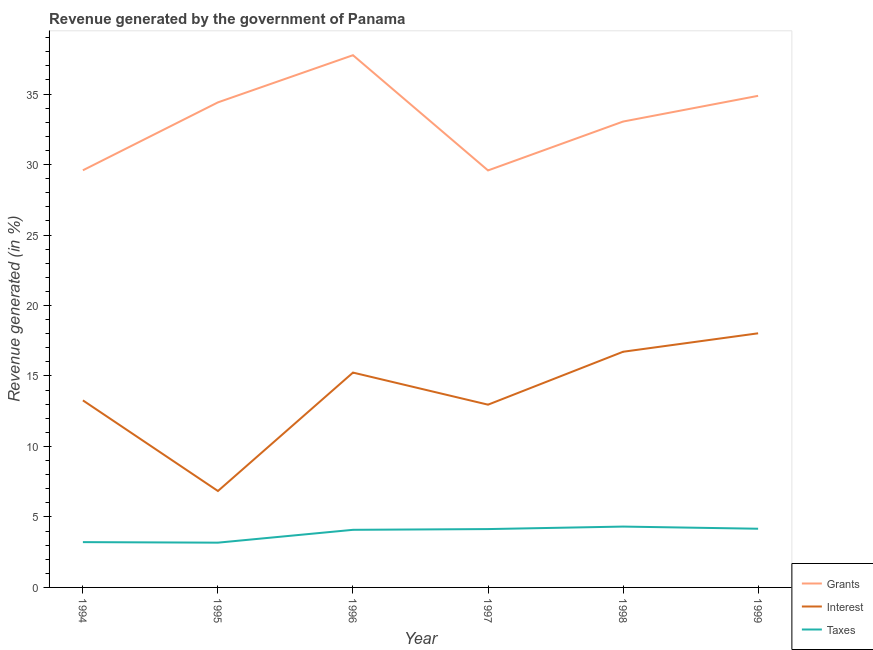How many different coloured lines are there?
Offer a very short reply. 3. Is the number of lines equal to the number of legend labels?
Your answer should be compact. Yes. What is the percentage of revenue generated by taxes in 1996?
Offer a terse response. 4.09. Across all years, what is the maximum percentage of revenue generated by interest?
Your answer should be compact. 18.03. Across all years, what is the minimum percentage of revenue generated by taxes?
Your answer should be compact. 3.18. In which year was the percentage of revenue generated by grants minimum?
Offer a very short reply. 1997. What is the total percentage of revenue generated by grants in the graph?
Your response must be concise. 199.27. What is the difference between the percentage of revenue generated by taxes in 1994 and that in 1996?
Offer a very short reply. -0.87. What is the difference between the percentage of revenue generated by grants in 1994 and the percentage of revenue generated by taxes in 1998?
Your response must be concise. 25.28. What is the average percentage of revenue generated by taxes per year?
Ensure brevity in your answer.  3.85. In the year 1996, what is the difference between the percentage of revenue generated by grants and percentage of revenue generated by interest?
Your answer should be compact. 22.52. In how many years, is the percentage of revenue generated by interest greater than 29 %?
Provide a succinct answer. 0. What is the ratio of the percentage of revenue generated by interest in 1994 to that in 1999?
Your answer should be very brief. 0.74. Is the percentage of revenue generated by grants in 1998 less than that in 1999?
Provide a succinct answer. Yes. Is the difference between the percentage of revenue generated by interest in 1994 and 1996 greater than the difference between the percentage of revenue generated by grants in 1994 and 1996?
Make the answer very short. Yes. What is the difference between the highest and the second highest percentage of revenue generated by taxes?
Give a very brief answer. 0.15. What is the difference between the highest and the lowest percentage of revenue generated by taxes?
Provide a succinct answer. 1.14. In how many years, is the percentage of revenue generated by interest greater than the average percentage of revenue generated by interest taken over all years?
Your answer should be compact. 3. Is the sum of the percentage of revenue generated by interest in 1994 and 1995 greater than the maximum percentage of revenue generated by grants across all years?
Offer a terse response. No. Is it the case that in every year, the sum of the percentage of revenue generated by grants and percentage of revenue generated by interest is greater than the percentage of revenue generated by taxes?
Give a very brief answer. Yes. How many years are there in the graph?
Provide a short and direct response. 6. What is the difference between two consecutive major ticks on the Y-axis?
Provide a short and direct response. 5. Are the values on the major ticks of Y-axis written in scientific E-notation?
Provide a short and direct response. No. How many legend labels are there?
Your answer should be very brief. 3. How are the legend labels stacked?
Offer a very short reply. Vertical. What is the title of the graph?
Provide a succinct answer. Revenue generated by the government of Panama. What is the label or title of the Y-axis?
Provide a succinct answer. Revenue generated (in %). What is the Revenue generated (in %) of Grants in 1994?
Offer a terse response. 29.59. What is the Revenue generated (in %) in Interest in 1994?
Keep it short and to the point. 13.27. What is the Revenue generated (in %) in Taxes in 1994?
Offer a terse response. 3.21. What is the Revenue generated (in %) in Grants in 1995?
Give a very brief answer. 34.41. What is the Revenue generated (in %) in Interest in 1995?
Offer a very short reply. 6.84. What is the Revenue generated (in %) in Taxes in 1995?
Your answer should be compact. 3.18. What is the Revenue generated (in %) of Grants in 1996?
Your answer should be compact. 37.76. What is the Revenue generated (in %) in Interest in 1996?
Your answer should be very brief. 15.24. What is the Revenue generated (in %) of Taxes in 1996?
Your answer should be very brief. 4.09. What is the Revenue generated (in %) of Grants in 1997?
Your answer should be compact. 29.58. What is the Revenue generated (in %) in Interest in 1997?
Your answer should be compact. 12.96. What is the Revenue generated (in %) of Taxes in 1997?
Your response must be concise. 4.14. What is the Revenue generated (in %) of Grants in 1998?
Your answer should be very brief. 33.05. What is the Revenue generated (in %) of Interest in 1998?
Ensure brevity in your answer.  16.72. What is the Revenue generated (in %) in Taxes in 1998?
Provide a short and direct response. 4.32. What is the Revenue generated (in %) of Grants in 1999?
Your answer should be very brief. 34.88. What is the Revenue generated (in %) in Interest in 1999?
Make the answer very short. 18.03. What is the Revenue generated (in %) in Taxes in 1999?
Ensure brevity in your answer.  4.16. Across all years, what is the maximum Revenue generated (in %) of Grants?
Your answer should be very brief. 37.76. Across all years, what is the maximum Revenue generated (in %) in Interest?
Your answer should be very brief. 18.03. Across all years, what is the maximum Revenue generated (in %) of Taxes?
Your answer should be compact. 4.32. Across all years, what is the minimum Revenue generated (in %) of Grants?
Ensure brevity in your answer.  29.58. Across all years, what is the minimum Revenue generated (in %) in Interest?
Offer a terse response. 6.84. Across all years, what is the minimum Revenue generated (in %) of Taxes?
Ensure brevity in your answer.  3.18. What is the total Revenue generated (in %) in Grants in the graph?
Your answer should be very brief. 199.27. What is the total Revenue generated (in %) in Interest in the graph?
Keep it short and to the point. 83.06. What is the total Revenue generated (in %) of Taxes in the graph?
Make the answer very short. 23.1. What is the difference between the Revenue generated (in %) of Grants in 1994 and that in 1995?
Your answer should be compact. -4.82. What is the difference between the Revenue generated (in %) in Interest in 1994 and that in 1995?
Offer a very short reply. 6.43. What is the difference between the Revenue generated (in %) in Taxes in 1994 and that in 1995?
Your answer should be very brief. 0.04. What is the difference between the Revenue generated (in %) of Grants in 1994 and that in 1996?
Keep it short and to the point. -8.17. What is the difference between the Revenue generated (in %) in Interest in 1994 and that in 1996?
Provide a succinct answer. -1.97. What is the difference between the Revenue generated (in %) in Taxes in 1994 and that in 1996?
Keep it short and to the point. -0.87. What is the difference between the Revenue generated (in %) in Grants in 1994 and that in 1997?
Keep it short and to the point. 0.01. What is the difference between the Revenue generated (in %) of Interest in 1994 and that in 1997?
Make the answer very short. 0.31. What is the difference between the Revenue generated (in %) in Taxes in 1994 and that in 1997?
Offer a terse response. -0.93. What is the difference between the Revenue generated (in %) of Grants in 1994 and that in 1998?
Offer a terse response. -3.46. What is the difference between the Revenue generated (in %) of Interest in 1994 and that in 1998?
Your answer should be very brief. -3.45. What is the difference between the Revenue generated (in %) of Taxes in 1994 and that in 1998?
Your answer should be compact. -1.1. What is the difference between the Revenue generated (in %) in Grants in 1994 and that in 1999?
Your answer should be very brief. -5.28. What is the difference between the Revenue generated (in %) in Interest in 1994 and that in 1999?
Provide a succinct answer. -4.76. What is the difference between the Revenue generated (in %) in Taxes in 1994 and that in 1999?
Ensure brevity in your answer.  -0.95. What is the difference between the Revenue generated (in %) in Grants in 1995 and that in 1996?
Your answer should be very brief. -3.35. What is the difference between the Revenue generated (in %) in Interest in 1995 and that in 1996?
Make the answer very short. -8.4. What is the difference between the Revenue generated (in %) of Taxes in 1995 and that in 1996?
Provide a short and direct response. -0.91. What is the difference between the Revenue generated (in %) of Grants in 1995 and that in 1997?
Provide a short and direct response. 4.83. What is the difference between the Revenue generated (in %) in Interest in 1995 and that in 1997?
Give a very brief answer. -6.13. What is the difference between the Revenue generated (in %) of Taxes in 1995 and that in 1997?
Your response must be concise. -0.96. What is the difference between the Revenue generated (in %) of Grants in 1995 and that in 1998?
Make the answer very short. 1.36. What is the difference between the Revenue generated (in %) in Interest in 1995 and that in 1998?
Make the answer very short. -9.88. What is the difference between the Revenue generated (in %) of Taxes in 1995 and that in 1998?
Offer a terse response. -1.14. What is the difference between the Revenue generated (in %) in Grants in 1995 and that in 1999?
Offer a terse response. -0.46. What is the difference between the Revenue generated (in %) of Interest in 1995 and that in 1999?
Your answer should be compact. -11.19. What is the difference between the Revenue generated (in %) of Taxes in 1995 and that in 1999?
Your response must be concise. -0.99. What is the difference between the Revenue generated (in %) in Grants in 1996 and that in 1997?
Provide a short and direct response. 8.17. What is the difference between the Revenue generated (in %) of Interest in 1996 and that in 1997?
Your answer should be very brief. 2.28. What is the difference between the Revenue generated (in %) in Taxes in 1996 and that in 1997?
Ensure brevity in your answer.  -0.05. What is the difference between the Revenue generated (in %) of Grants in 1996 and that in 1998?
Give a very brief answer. 4.71. What is the difference between the Revenue generated (in %) of Interest in 1996 and that in 1998?
Provide a succinct answer. -1.48. What is the difference between the Revenue generated (in %) in Taxes in 1996 and that in 1998?
Provide a short and direct response. -0.23. What is the difference between the Revenue generated (in %) of Grants in 1996 and that in 1999?
Provide a succinct answer. 2.88. What is the difference between the Revenue generated (in %) in Interest in 1996 and that in 1999?
Offer a very short reply. -2.79. What is the difference between the Revenue generated (in %) of Taxes in 1996 and that in 1999?
Keep it short and to the point. -0.08. What is the difference between the Revenue generated (in %) of Grants in 1997 and that in 1998?
Offer a very short reply. -3.47. What is the difference between the Revenue generated (in %) of Interest in 1997 and that in 1998?
Your response must be concise. -3.75. What is the difference between the Revenue generated (in %) of Taxes in 1997 and that in 1998?
Your response must be concise. -0.18. What is the difference between the Revenue generated (in %) of Grants in 1997 and that in 1999?
Offer a very short reply. -5.29. What is the difference between the Revenue generated (in %) in Interest in 1997 and that in 1999?
Your answer should be compact. -5.06. What is the difference between the Revenue generated (in %) of Taxes in 1997 and that in 1999?
Ensure brevity in your answer.  -0.03. What is the difference between the Revenue generated (in %) in Grants in 1998 and that in 1999?
Give a very brief answer. -1.82. What is the difference between the Revenue generated (in %) in Interest in 1998 and that in 1999?
Keep it short and to the point. -1.31. What is the difference between the Revenue generated (in %) of Taxes in 1998 and that in 1999?
Ensure brevity in your answer.  0.15. What is the difference between the Revenue generated (in %) of Grants in 1994 and the Revenue generated (in %) of Interest in 1995?
Your answer should be very brief. 22.75. What is the difference between the Revenue generated (in %) of Grants in 1994 and the Revenue generated (in %) of Taxes in 1995?
Give a very brief answer. 26.42. What is the difference between the Revenue generated (in %) in Interest in 1994 and the Revenue generated (in %) in Taxes in 1995?
Your response must be concise. 10.09. What is the difference between the Revenue generated (in %) of Grants in 1994 and the Revenue generated (in %) of Interest in 1996?
Your response must be concise. 14.35. What is the difference between the Revenue generated (in %) of Grants in 1994 and the Revenue generated (in %) of Taxes in 1996?
Your response must be concise. 25.51. What is the difference between the Revenue generated (in %) in Interest in 1994 and the Revenue generated (in %) in Taxes in 1996?
Give a very brief answer. 9.18. What is the difference between the Revenue generated (in %) of Grants in 1994 and the Revenue generated (in %) of Interest in 1997?
Make the answer very short. 16.63. What is the difference between the Revenue generated (in %) of Grants in 1994 and the Revenue generated (in %) of Taxes in 1997?
Your answer should be very brief. 25.45. What is the difference between the Revenue generated (in %) of Interest in 1994 and the Revenue generated (in %) of Taxes in 1997?
Make the answer very short. 9.13. What is the difference between the Revenue generated (in %) of Grants in 1994 and the Revenue generated (in %) of Interest in 1998?
Keep it short and to the point. 12.87. What is the difference between the Revenue generated (in %) in Grants in 1994 and the Revenue generated (in %) in Taxes in 1998?
Give a very brief answer. 25.28. What is the difference between the Revenue generated (in %) of Interest in 1994 and the Revenue generated (in %) of Taxes in 1998?
Make the answer very short. 8.95. What is the difference between the Revenue generated (in %) in Grants in 1994 and the Revenue generated (in %) in Interest in 1999?
Offer a very short reply. 11.56. What is the difference between the Revenue generated (in %) of Grants in 1994 and the Revenue generated (in %) of Taxes in 1999?
Keep it short and to the point. 25.43. What is the difference between the Revenue generated (in %) in Interest in 1994 and the Revenue generated (in %) in Taxes in 1999?
Keep it short and to the point. 9.11. What is the difference between the Revenue generated (in %) of Grants in 1995 and the Revenue generated (in %) of Interest in 1996?
Offer a very short reply. 19.17. What is the difference between the Revenue generated (in %) of Grants in 1995 and the Revenue generated (in %) of Taxes in 1996?
Keep it short and to the point. 30.32. What is the difference between the Revenue generated (in %) of Interest in 1995 and the Revenue generated (in %) of Taxes in 1996?
Offer a terse response. 2.75. What is the difference between the Revenue generated (in %) of Grants in 1995 and the Revenue generated (in %) of Interest in 1997?
Your answer should be compact. 21.45. What is the difference between the Revenue generated (in %) in Grants in 1995 and the Revenue generated (in %) in Taxes in 1997?
Make the answer very short. 30.27. What is the difference between the Revenue generated (in %) of Interest in 1995 and the Revenue generated (in %) of Taxes in 1997?
Ensure brevity in your answer.  2.7. What is the difference between the Revenue generated (in %) of Grants in 1995 and the Revenue generated (in %) of Interest in 1998?
Offer a terse response. 17.69. What is the difference between the Revenue generated (in %) in Grants in 1995 and the Revenue generated (in %) in Taxes in 1998?
Offer a very short reply. 30.09. What is the difference between the Revenue generated (in %) of Interest in 1995 and the Revenue generated (in %) of Taxes in 1998?
Your answer should be very brief. 2.52. What is the difference between the Revenue generated (in %) in Grants in 1995 and the Revenue generated (in %) in Interest in 1999?
Ensure brevity in your answer.  16.38. What is the difference between the Revenue generated (in %) in Grants in 1995 and the Revenue generated (in %) in Taxes in 1999?
Your response must be concise. 30.25. What is the difference between the Revenue generated (in %) of Interest in 1995 and the Revenue generated (in %) of Taxes in 1999?
Provide a succinct answer. 2.68. What is the difference between the Revenue generated (in %) of Grants in 1996 and the Revenue generated (in %) of Interest in 1997?
Provide a short and direct response. 24.79. What is the difference between the Revenue generated (in %) in Grants in 1996 and the Revenue generated (in %) in Taxes in 1997?
Your response must be concise. 33.62. What is the difference between the Revenue generated (in %) in Interest in 1996 and the Revenue generated (in %) in Taxes in 1997?
Your response must be concise. 11.1. What is the difference between the Revenue generated (in %) in Grants in 1996 and the Revenue generated (in %) in Interest in 1998?
Provide a short and direct response. 21.04. What is the difference between the Revenue generated (in %) of Grants in 1996 and the Revenue generated (in %) of Taxes in 1998?
Make the answer very short. 33.44. What is the difference between the Revenue generated (in %) of Interest in 1996 and the Revenue generated (in %) of Taxes in 1998?
Give a very brief answer. 10.93. What is the difference between the Revenue generated (in %) in Grants in 1996 and the Revenue generated (in %) in Interest in 1999?
Offer a terse response. 19.73. What is the difference between the Revenue generated (in %) of Grants in 1996 and the Revenue generated (in %) of Taxes in 1999?
Your answer should be very brief. 33.59. What is the difference between the Revenue generated (in %) of Interest in 1996 and the Revenue generated (in %) of Taxes in 1999?
Make the answer very short. 11.08. What is the difference between the Revenue generated (in %) in Grants in 1997 and the Revenue generated (in %) in Interest in 1998?
Your response must be concise. 12.86. What is the difference between the Revenue generated (in %) of Grants in 1997 and the Revenue generated (in %) of Taxes in 1998?
Offer a very short reply. 25.27. What is the difference between the Revenue generated (in %) of Interest in 1997 and the Revenue generated (in %) of Taxes in 1998?
Offer a very short reply. 8.65. What is the difference between the Revenue generated (in %) of Grants in 1997 and the Revenue generated (in %) of Interest in 1999?
Provide a short and direct response. 11.56. What is the difference between the Revenue generated (in %) in Grants in 1997 and the Revenue generated (in %) in Taxes in 1999?
Provide a succinct answer. 25.42. What is the difference between the Revenue generated (in %) of Interest in 1997 and the Revenue generated (in %) of Taxes in 1999?
Make the answer very short. 8.8. What is the difference between the Revenue generated (in %) in Grants in 1998 and the Revenue generated (in %) in Interest in 1999?
Ensure brevity in your answer.  15.02. What is the difference between the Revenue generated (in %) of Grants in 1998 and the Revenue generated (in %) of Taxes in 1999?
Give a very brief answer. 28.89. What is the difference between the Revenue generated (in %) of Interest in 1998 and the Revenue generated (in %) of Taxes in 1999?
Keep it short and to the point. 12.55. What is the average Revenue generated (in %) of Grants per year?
Your response must be concise. 33.21. What is the average Revenue generated (in %) of Interest per year?
Offer a terse response. 13.84. What is the average Revenue generated (in %) of Taxes per year?
Your response must be concise. 3.85. In the year 1994, what is the difference between the Revenue generated (in %) of Grants and Revenue generated (in %) of Interest?
Make the answer very short. 16.32. In the year 1994, what is the difference between the Revenue generated (in %) in Grants and Revenue generated (in %) in Taxes?
Make the answer very short. 26.38. In the year 1994, what is the difference between the Revenue generated (in %) in Interest and Revenue generated (in %) in Taxes?
Provide a succinct answer. 10.06. In the year 1995, what is the difference between the Revenue generated (in %) in Grants and Revenue generated (in %) in Interest?
Provide a short and direct response. 27.57. In the year 1995, what is the difference between the Revenue generated (in %) of Grants and Revenue generated (in %) of Taxes?
Provide a succinct answer. 31.24. In the year 1995, what is the difference between the Revenue generated (in %) of Interest and Revenue generated (in %) of Taxes?
Offer a very short reply. 3.66. In the year 1996, what is the difference between the Revenue generated (in %) of Grants and Revenue generated (in %) of Interest?
Make the answer very short. 22.52. In the year 1996, what is the difference between the Revenue generated (in %) in Grants and Revenue generated (in %) in Taxes?
Your answer should be very brief. 33.67. In the year 1996, what is the difference between the Revenue generated (in %) in Interest and Revenue generated (in %) in Taxes?
Offer a terse response. 11.16. In the year 1997, what is the difference between the Revenue generated (in %) in Grants and Revenue generated (in %) in Interest?
Give a very brief answer. 16.62. In the year 1997, what is the difference between the Revenue generated (in %) of Grants and Revenue generated (in %) of Taxes?
Make the answer very short. 25.44. In the year 1997, what is the difference between the Revenue generated (in %) of Interest and Revenue generated (in %) of Taxes?
Your answer should be very brief. 8.83. In the year 1998, what is the difference between the Revenue generated (in %) in Grants and Revenue generated (in %) in Interest?
Make the answer very short. 16.33. In the year 1998, what is the difference between the Revenue generated (in %) in Grants and Revenue generated (in %) in Taxes?
Give a very brief answer. 28.73. In the year 1998, what is the difference between the Revenue generated (in %) of Interest and Revenue generated (in %) of Taxes?
Ensure brevity in your answer.  12.4. In the year 1999, what is the difference between the Revenue generated (in %) of Grants and Revenue generated (in %) of Interest?
Your answer should be compact. 16.85. In the year 1999, what is the difference between the Revenue generated (in %) in Grants and Revenue generated (in %) in Taxes?
Keep it short and to the point. 30.71. In the year 1999, what is the difference between the Revenue generated (in %) in Interest and Revenue generated (in %) in Taxes?
Ensure brevity in your answer.  13.86. What is the ratio of the Revenue generated (in %) of Grants in 1994 to that in 1995?
Your answer should be compact. 0.86. What is the ratio of the Revenue generated (in %) of Interest in 1994 to that in 1995?
Keep it short and to the point. 1.94. What is the ratio of the Revenue generated (in %) of Taxes in 1994 to that in 1995?
Your response must be concise. 1.01. What is the ratio of the Revenue generated (in %) of Grants in 1994 to that in 1996?
Keep it short and to the point. 0.78. What is the ratio of the Revenue generated (in %) in Interest in 1994 to that in 1996?
Your answer should be compact. 0.87. What is the ratio of the Revenue generated (in %) of Taxes in 1994 to that in 1996?
Provide a succinct answer. 0.79. What is the ratio of the Revenue generated (in %) in Interest in 1994 to that in 1997?
Ensure brevity in your answer.  1.02. What is the ratio of the Revenue generated (in %) of Taxes in 1994 to that in 1997?
Keep it short and to the point. 0.78. What is the ratio of the Revenue generated (in %) of Grants in 1994 to that in 1998?
Ensure brevity in your answer.  0.9. What is the ratio of the Revenue generated (in %) in Interest in 1994 to that in 1998?
Ensure brevity in your answer.  0.79. What is the ratio of the Revenue generated (in %) in Taxes in 1994 to that in 1998?
Provide a short and direct response. 0.74. What is the ratio of the Revenue generated (in %) in Grants in 1994 to that in 1999?
Keep it short and to the point. 0.85. What is the ratio of the Revenue generated (in %) in Interest in 1994 to that in 1999?
Offer a terse response. 0.74. What is the ratio of the Revenue generated (in %) of Taxes in 1994 to that in 1999?
Your answer should be compact. 0.77. What is the ratio of the Revenue generated (in %) of Grants in 1995 to that in 1996?
Make the answer very short. 0.91. What is the ratio of the Revenue generated (in %) in Interest in 1995 to that in 1996?
Offer a very short reply. 0.45. What is the ratio of the Revenue generated (in %) of Taxes in 1995 to that in 1996?
Your answer should be very brief. 0.78. What is the ratio of the Revenue generated (in %) in Grants in 1995 to that in 1997?
Your response must be concise. 1.16. What is the ratio of the Revenue generated (in %) of Interest in 1995 to that in 1997?
Your answer should be compact. 0.53. What is the ratio of the Revenue generated (in %) of Taxes in 1995 to that in 1997?
Provide a succinct answer. 0.77. What is the ratio of the Revenue generated (in %) in Grants in 1995 to that in 1998?
Your response must be concise. 1.04. What is the ratio of the Revenue generated (in %) in Interest in 1995 to that in 1998?
Your response must be concise. 0.41. What is the ratio of the Revenue generated (in %) of Taxes in 1995 to that in 1998?
Your answer should be very brief. 0.74. What is the ratio of the Revenue generated (in %) in Grants in 1995 to that in 1999?
Offer a terse response. 0.99. What is the ratio of the Revenue generated (in %) in Interest in 1995 to that in 1999?
Provide a short and direct response. 0.38. What is the ratio of the Revenue generated (in %) of Taxes in 1995 to that in 1999?
Offer a terse response. 0.76. What is the ratio of the Revenue generated (in %) of Grants in 1996 to that in 1997?
Ensure brevity in your answer.  1.28. What is the ratio of the Revenue generated (in %) of Interest in 1996 to that in 1997?
Your answer should be compact. 1.18. What is the ratio of the Revenue generated (in %) of Taxes in 1996 to that in 1997?
Offer a terse response. 0.99. What is the ratio of the Revenue generated (in %) in Grants in 1996 to that in 1998?
Offer a very short reply. 1.14. What is the ratio of the Revenue generated (in %) of Interest in 1996 to that in 1998?
Make the answer very short. 0.91. What is the ratio of the Revenue generated (in %) of Taxes in 1996 to that in 1998?
Your answer should be very brief. 0.95. What is the ratio of the Revenue generated (in %) of Grants in 1996 to that in 1999?
Offer a terse response. 1.08. What is the ratio of the Revenue generated (in %) of Interest in 1996 to that in 1999?
Your answer should be compact. 0.85. What is the ratio of the Revenue generated (in %) of Taxes in 1996 to that in 1999?
Keep it short and to the point. 0.98. What is the ratio of the Revenue generated (in %) of Grants in 1997 to that in 1998?
Keep it short and to the point. 0.9. What is the ratio of the Revenue generated (in %) of Interest in 1997 to that in 1998?
Give a very brief answer. 0.78. What is the ratio of the Revenue generated (in %) of Taxes in 1997 to that in 1998?
Provide a short and direct response. 0.96. What is the ratio of the Revenue generated (in %) in Grants in 1997 to that in 1999?
Your response must be concise. 0.85. What is the ratio of the Revenue generated (in %) of Interest in 1997 to that in 1999?
Your response must be concise. 0.72. What is the ratio of the Revenue generated (in %) of Taxes in 1997 to that in 1999?
Offer a terse response. 0.99. What is the ratio of the Revenue generated (in %) of Grants in 1998 to that in 1999?
Your answer should be very brief. 0.95. What is the ratio of the Revenue generated (in %) in Interest in 1998 to that in 1999?
Provide a short and direct response. 0.93. What is the ratio of the Revenue generated (in %) of Taxes in 1998 to that in 1999?
Provide a succinct answer. 1.04. What is the difference between the highest and the second highest Revenue generated (in %) of Grants?
Your response must be concise. 2.88. What is the difference between the highest and the second highest Revenue generated (in %) in Interest?
Keep it short and to the point. 1.31. What is the difference between the highest and the second highest Revenue generated (in %) of Taxes?
Ensure brevity in your answer.  0.15. What is the difference between the highest and the lowest Revenue generated (in %) of Grants?
Give a very brief answer. 8.17. What is the difference between the highest and the lowest Revenue generated (in %) in Interest?
Offer a very short reply. 11.19. What is the difference between the highest and the lowest Revenue generated (in %) of Taxes?
Keep it short and to the point. 1.14. 